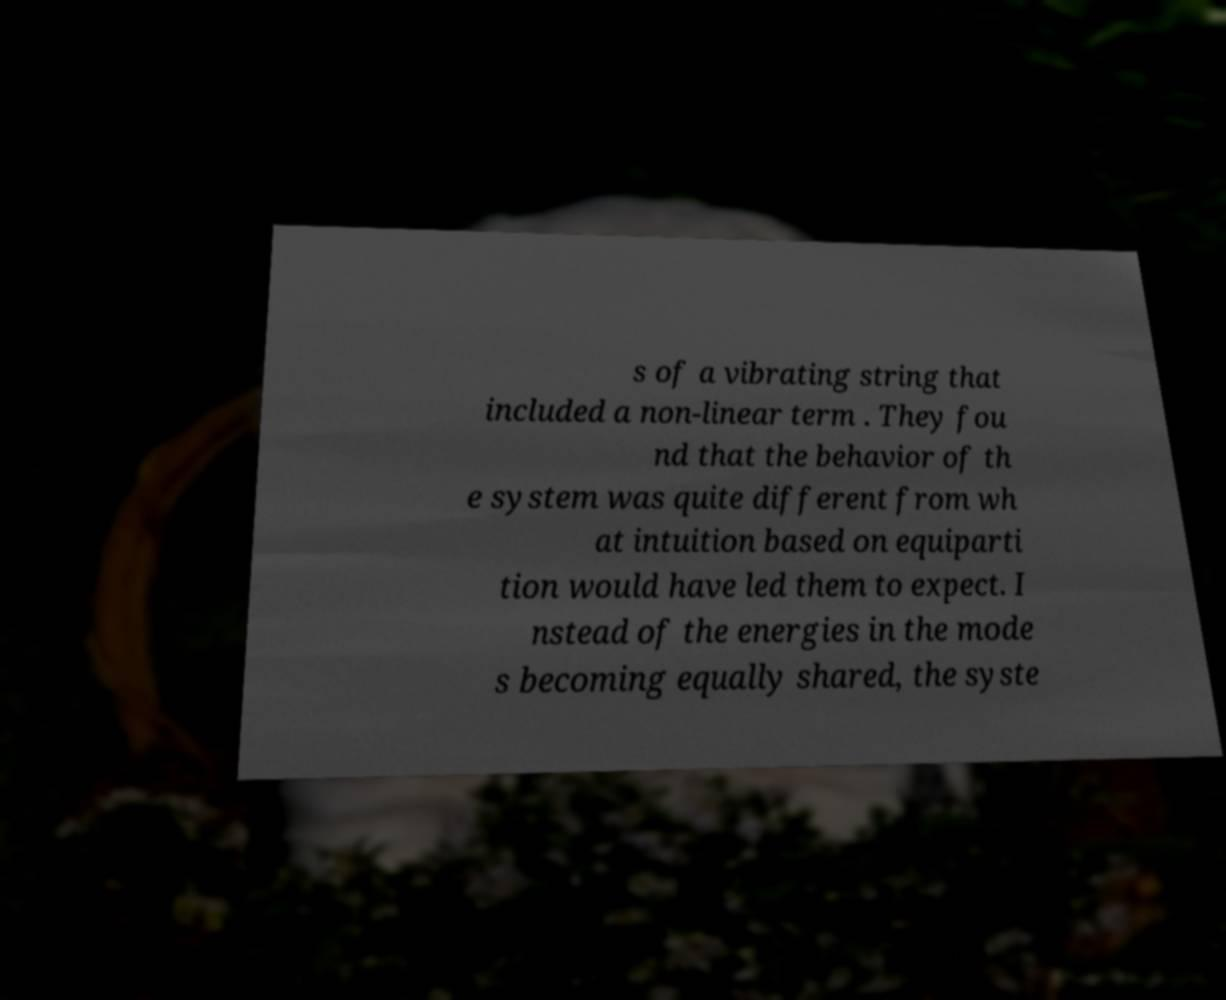Please read and relay the text visible in this image. What does it say? s of a vibrating string that included a non-linear term . They fou nd that the behavior of th e system was quite different from wh at intuition based on equiparti tion would have led them to expect. I nstead of the energies in the mode s becoming equally shared, the syste 